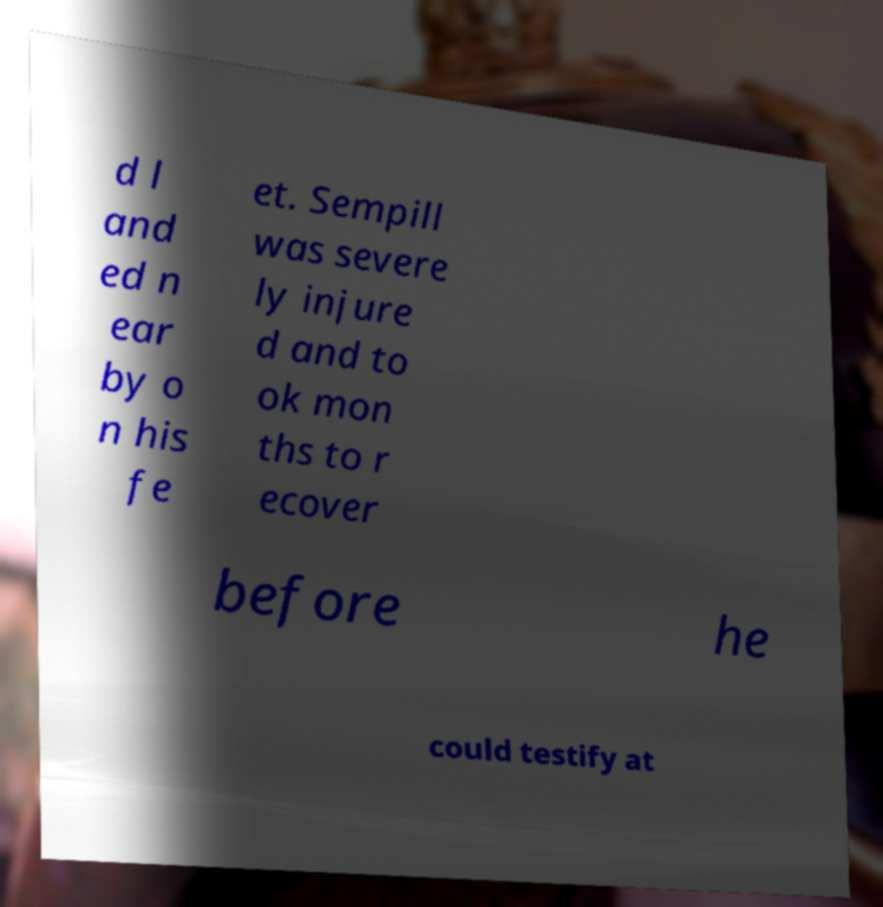Please read and relay the text visible in this image. What does it say? d l and ed n ear by o n his fe et. Sempill was severe ly injure d and to ok mon ths to r ecover before he could testify at 